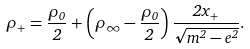Convert formula to latex. <formula><loc_0><loc_0><loc_500><loc_500>\rho _ { + } = \frac { \rho _ { 0 } } { 2 } + \left ( \rho _ { \infty } - \frac { \rho _ { 0 } } { 2 } \right ) \frac { 2 x _ { + } } { \sqrt { m ^ { 2 } - e ^ { 2 } } } .</formula> 